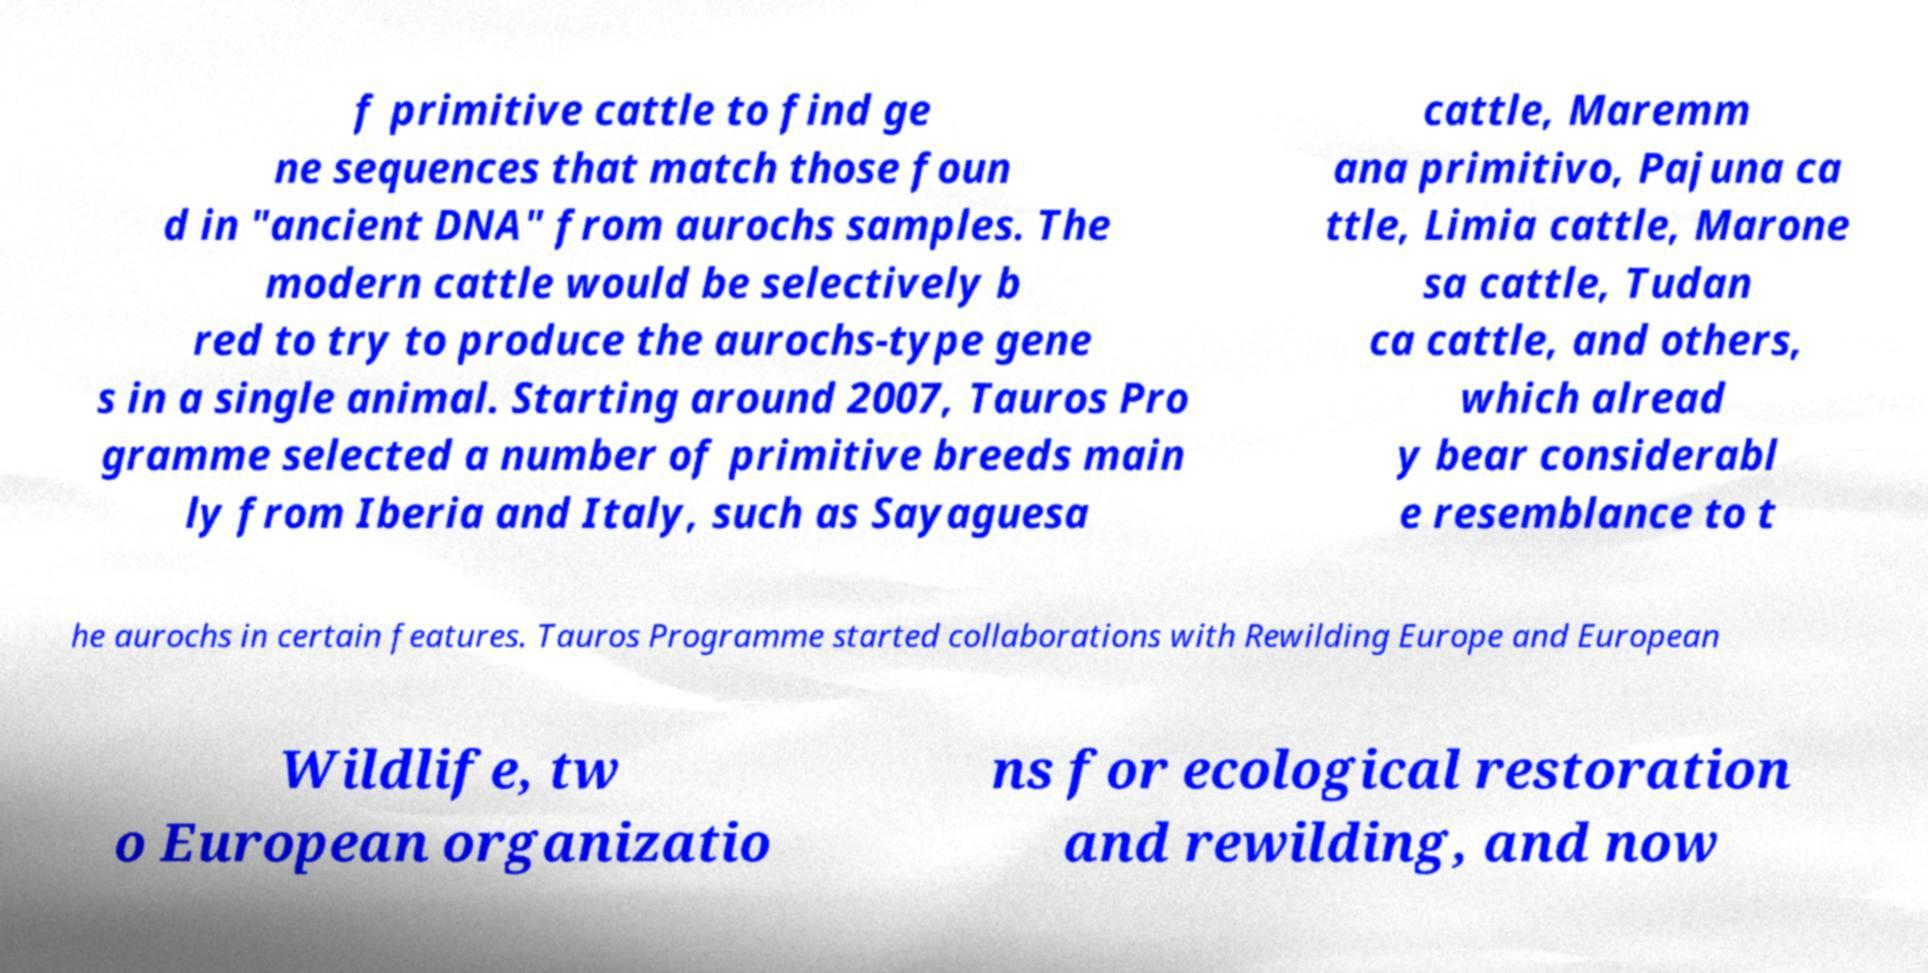I need the written content from this picture converted into text. Can you do that? f primitive cattle to find ge ne sequences that match those foun d in "ancient DNA" from aurochs samples. The modern cattle would be selectively b red to try to produce the aurochs-type gene s in a single animal. Starting around 2007, Tauros Pro gramme selected a number of primitive breeds main ly from Iberia and Italy, such as Sayaguesa cattle, Maremm ana primitivo, Pajuna ca ttle, Limia cattle, Marone sa cattle, Tudan ca cattle, and others, which alread y bear considerabl e resemblance to t he aurochs in certain features. Tauros Programme started collaborations with Rewilding Europe and European Wildlife, tw o European organizatio ns for ecological restoration and rewilding, and now 